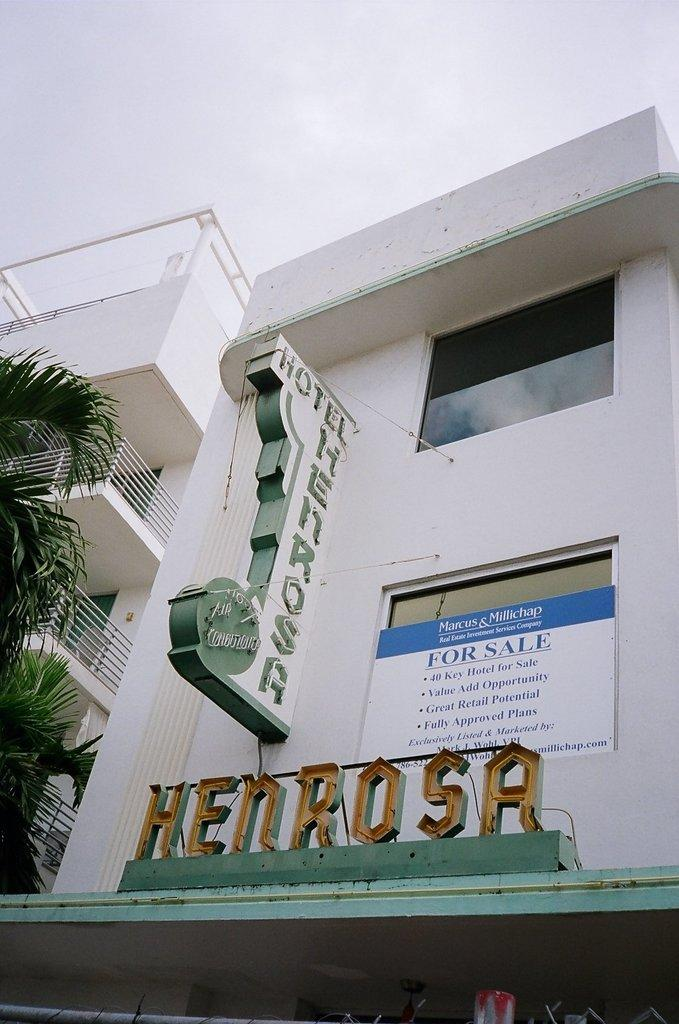What is the color of the building in the image? The building in the image is white. What is attached to the building? There are boards on the building. What is written on the boards? Words are written on the boards. What type of plant can be seen in the image? There is a tree visible in the image. What type of prose is being recited by the tree in the image? There is no indication in the image that the tree is reciting any prose, as trees do not have the ability to speak or recite literature. 